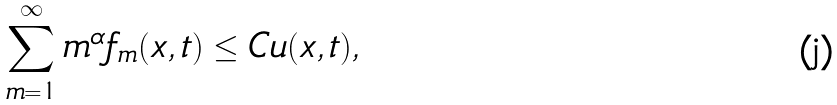<formula> <loc_0><loc_0><loc_500><loc_500>\sum _ { m = 1 } ^ { \infty } m ^ { \alpha } f _ { m } ( x , t ) \leq C u ( x , t ) ,</formula> 